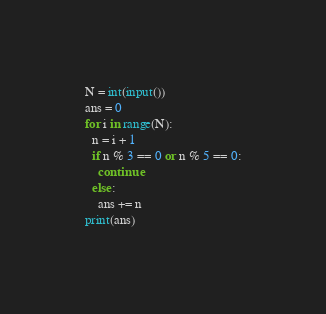<code> <loc_0><loc_0><loc_500><loc_500><_Python_>N = int(input())
ans = 0
for i in range(N):
  n = i + 1
  if n % 3 == 0 or n % 5 == 0:
    continue
  else:
    ans += n
print(ans)</code> 